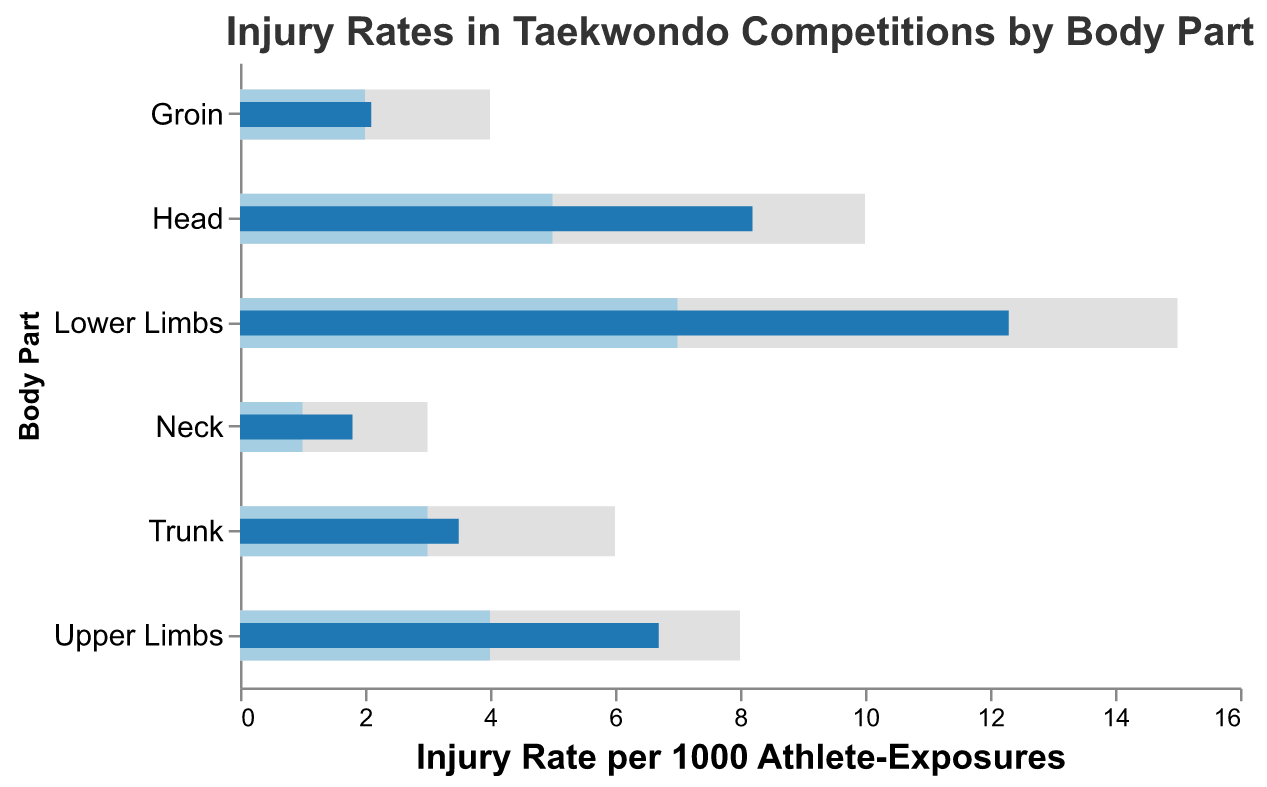What's the title of the chart? The title of the chart is displayed at the top of the figure. It reads "Injury Rates in Taekwondo Competitions by Body Part."
Answer: Injury Rates in Taekwondo Competitions by Body Part Which body part has the highest actual injury rate? By looking at the chart, the bar corresponding to the actual injury rate for each body part can be seen. The highest bar represents the Lower Limbs with the actual injury rate of 12.3.
Answer: Lower Limbs How much higher is the actual injury rate for Upper Limbs compared to the safety threshold? Find the actual injury rate (6.7) and the safety threshold (4) for Upper Limbs, and calculate the difference: 6.7 - 4.0 = 2.7.
Answer: 2.7 Does any body part exceed both its safety threshold and maximum acceptable rate? For each body part, evaluate whether the actual injury rate is above both the safety threshold and maximum acceptable rate. None of the body parts exceed both their safety threshold and maximum acceptable rate.
Answer: No How does the injury rate for the Head compare to its maximum acceptable rate? The actual injury rate of the Head (8.2) and its maximum acceptable rate (10) should be compared. 8.2 is less than 10, so the Head's injury rate is within the maximum acceptable range.
Answer: Less than What is the difference in safety threshold between the Trunk and Lower Limbs? Compare the safety thresholds for the Trunk (3) and Lower Limbs (7) and find the difference: 7 - 3 = 4.
Answer: 4 Are any body parts within their safety threshold? Compare the actual injury rates with their corresponding safety thresholds for each body part. Neck (1.8 vs 1) and Groin (2.1 vs 2) exceed their thresholds, while Trunk (3.5 vs 3), Lower Limbs (12.3 vs 7), and Upper Limbs (6.7 vs 4) also exceed their thresholds. No body part remains within its safety threshold.
Answer: No Which body part shows the smallest difference between its actual injury rate and maximum acceptable rate? Calculate the difference between the actual injury rate and the maximum acceptable rate for each body part, and identify the smallest. Neck has the smallest difference (3 - 1.8 = 1.2).
Answer: Neck What is the injury rate range for the head including the safety threshold and the actual rate? The injury rate range can be assessed by looking at the values for the Head. The safety threshold is 5, and the actual rate is 8.2.
Answer: From 5 to 8.2 Which body part has the closest actual injury rate to its safety threshold? Calculate the absolute differences between the actual injury rates and safety thresholds for each body part, and identify the smallest. The Trunk has the closest rate (3.5 vs 3, difference 0.5).
Answer: Trunk 